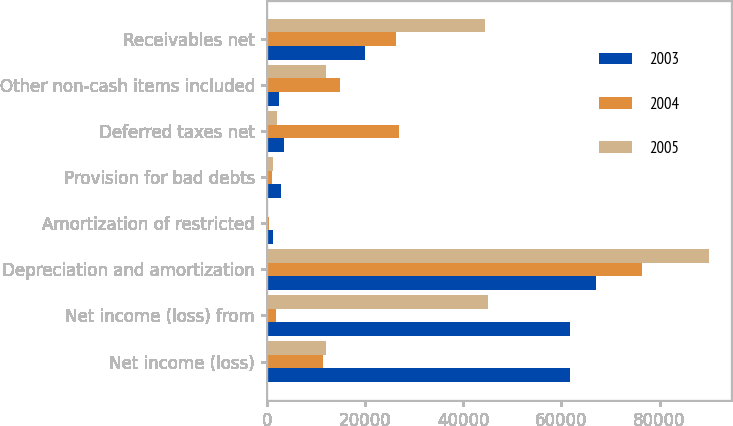Convert chart to OTSL. <chart><loc_0><loc_0><loc_500><loc_500><stacked_bar_chart><ecel><fcel>Net income (loss)<fcel>Net income (loss) from<fcel>Depreciation and amortization<fcel>Amortization of restricted<fcel>Provision for bad debts<fcel>Deferred taxes net<fcel>Other non-cash items included<fcel>Receivables net<nl><fcel>2003<fcel>61690<fcel>61690<fcel>66986<fcel>1358<fcel>2998<fcel>3469<fcel>2543<fcel>20083<nl><fcel>2004<fcel>11362<fcel>1804<fcel>76336<fcel>541<fcel>1074<fcel>26970<fcel>14987<fcel>26360<nl><fcel>2005<fcel>12151<fcel>45112<fcel>89983<fcel>50<fcel>1365<fcel>2103<fcel>12151<fcel>44500<nl></chart> 